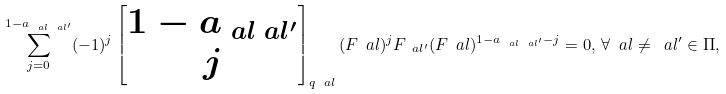Convert formula to latex. <formula><loc_0><loc_0><loc_500><loc_500>\sum _ { j = 0 } ^ { 1 - a _ { \ a l \ a l ^ { \prime } } } ( - 1 ) ^ { j } \begin{bmatrix} 1 - a _ { \ a l \ a l ^ { \prime } } \\ j \end{bmatrix} _ { q _ { \ } a l } ( F _ { \ } a l ) ^ { j } F _ { \ a l ^ { \prime } } ( F _ { \ } a l ) ^ { 1 - a _ { \ a l \ a l ^ { \prime } } - j } = 0 , \, \forall \ a l \neq \ a l ^ { \prime } \in \Pi ,</formula> 